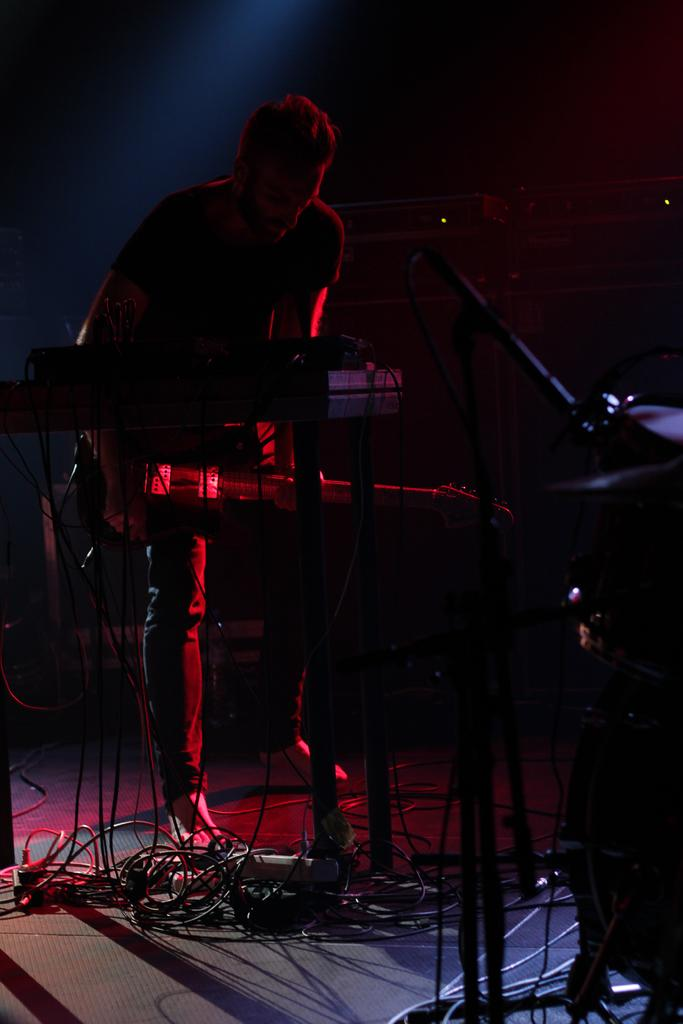What object is present in the image that is commonly used for amplifying sound? There is a microphone in the image. What activity is the person in the image engaged in? The person is playing a guitar in the image. What type of clouds can be seen in the image? There are no clouds present in the image; it only features a microphone and a person playing a guitar. How does the ant contribute to the musical performance in the image? There is no ant present in the image, and therefore it does not contribute to the musical performance. 